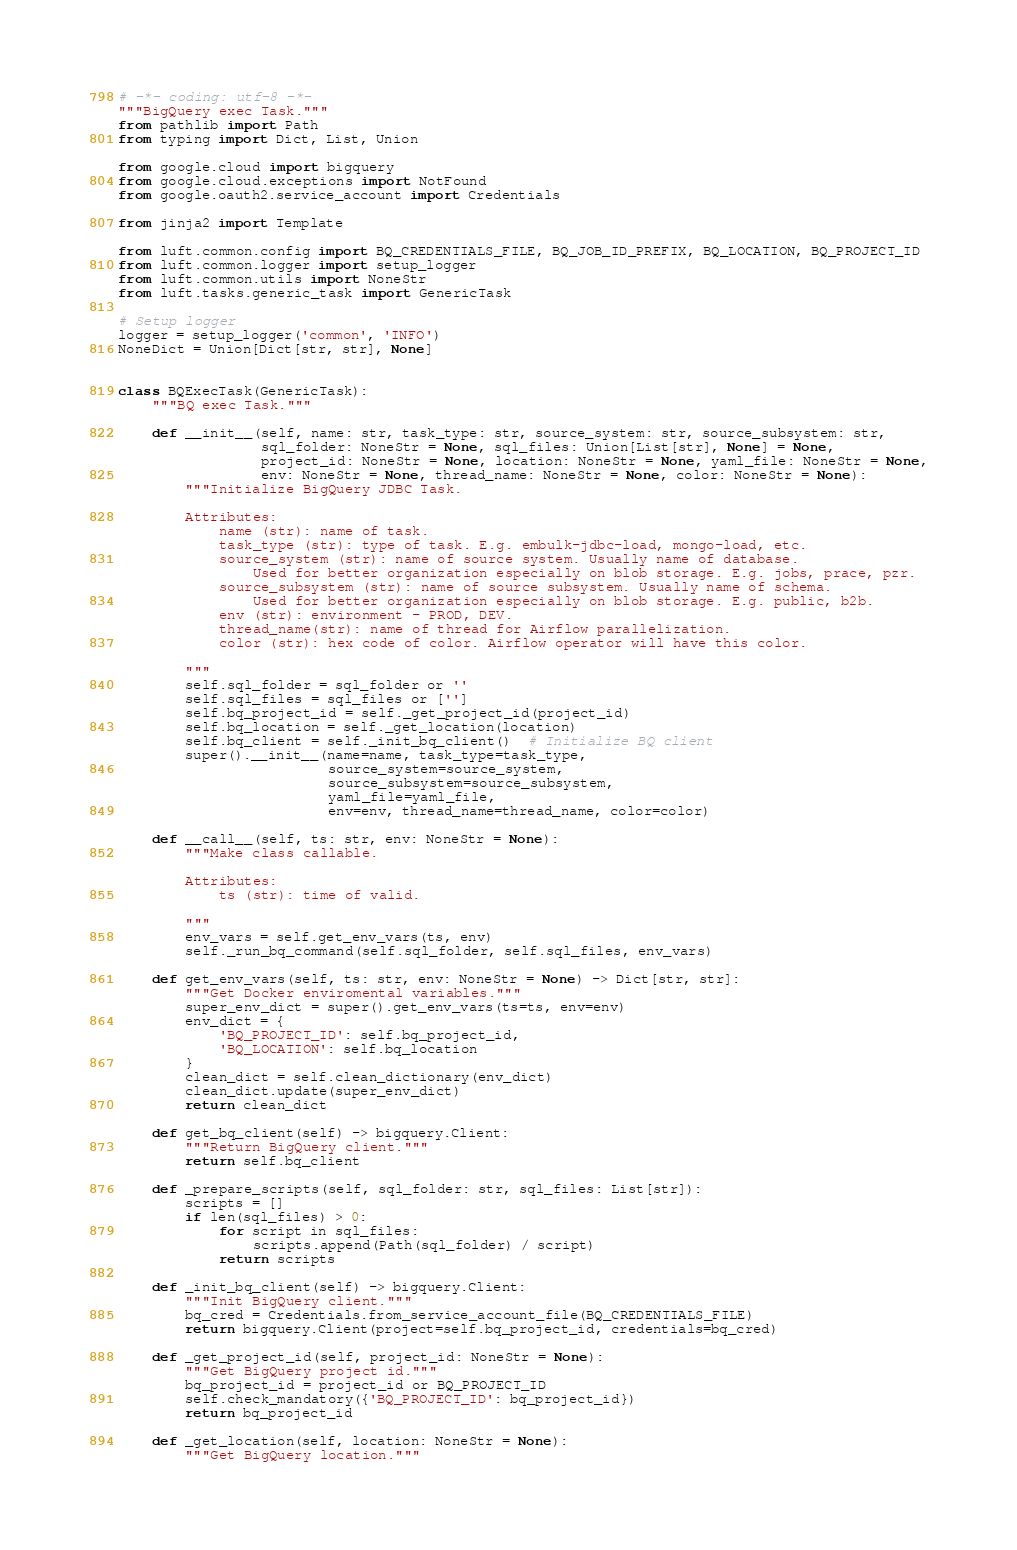<code> <loc_0><loc_0><loc_500><loc_500><_Python_># -*- coding: utf-8 -*-
"""BigQuery exec Task."""
from pathlib import Path
from typing import Dict, List, Union

from google.cloud import bigquery
from google.cloud.exceptions import NotFound
from google.oauth2.service_account import Credentials

from jinja2 import Template

from luft.common.config import BQ_CREDENTIALS_FILE, BQ_JOB_ID_PREFIX, BQ_LOCATION, BQ_PROJECT_ID
from luft.common.logger import setup_logger
from luft.common.utils import NoneStr
from luft.tasks.generic_task import GenericTask

# Setup logger
logger = setup_logger('common', 'INFO')
NoneDict = Union[Dict[str, str], None]


class BQExecTask(GenericTask):
    """BQ exec Task."""

    def __init__(self, name: str, task_type: str, source_system: str, source_subsystem: str,
                 sql_folder: NoneStr = None, sql_files: Union[List[str], None] = None,
                 project_id: NoneStr = None, location: NoneStr = None, yaml_file: NoneStr = None,
                 env: NoneStr = None, thread_name: NoneStr = None, color: NoneStr = None):
        """Initialize BigQuery JDBC Task.

        Attributes:
            name (str): name of task.
            task_type (str): type of task. E.g. embulk-jdbc-load, mongo-load, etc.
            source_system (str): name of source system. Usually name of database.
                Used for better organization especially on blob storage. E.g. jobs, prace, pzr.
            source_subsystem (str): name of source subsystem. Usually name of schema.
                Used for better organization especially on blob storage. E.g. public, b2b.
            env (str): environment - PROD, DEV.
            thread_name(str): name of thread for Airflow parallelization.
            color (str): hex code of color. Airflow operator will have this color.

        """
        self.sql_folder = sql_folder or ''
        self.sql_files = sql_files or ['']
        self.bq_project_id = self._get_project_id(project_id)
        self.bq_location = self._get_location(location)
        self.bq_client = self._init_bq_client()  # Initialize BQ client
        super().__init__(name=name, task_type=task_type,
                         source_system=source_system,
                         source_subsystem=source_subsystem,
                         yaml_file=yaml_file,
                         env=env, thread_name=thread_name, color=color)

    def __call__(self, ts: str, env: NoneStr = None):
        """Make class callable.

        Attributes:
            ts (str): time of valid.

        """
        env_vars = self.get_env_vars(ts, env)
        self._run_bq_command(self.sql_folder, self.sql_files, env_vars)

    def get_env_vars(self, ts: str, env: NoneStr = None) -> Dict[str, str]:
        """Get Docker enviromental variables."""
        super_env_dict = super().get_env_vars(ts=ts, env=env)
        env_dict = {
            'BQ_PROJECT_ID': self.bq_project_id,
            'BQ_LOCATION': self.bq_location
        }
        clean_dict = self.clean_dictionary(env_dict)
        clean_dict.update(super_env_dict)
        return clean_dict

    def get_bq_client(self) -> bigquery.Client:
        """Return BigQuery client."""
        return self.bq_client

    def _prepare_scripts(self, sql_folder: str, sql_files: List[str]):
        scripts = []
        if len(sql_files) > 0:
            for script in sql_files:
                scripts.append(Path(sql_folder) / script)
            return scripts

    def _init_bq_client(self) -> bigquery.Client:
        """Init BigQuery client."""
        bq_cred = Credentials.from_service_account_file(BQ_CREDENTIALS_FILE)
        return bigquery.Client(project=self.bq_project_id, credentials=bq_cred)

    def _get_project_id(self, project_id: NoneStr = None):
        """Get BigQuery project id."""
        bq_project_id = project_id or BQ_PROJECT_ID
        self.check_mandatory({'BQ_PROJECT_ID': bq_project_id})
        return bq_project_id

    def _get_location(self, location: NoneStr = None):
        """Get BigQuery location."""</code> 